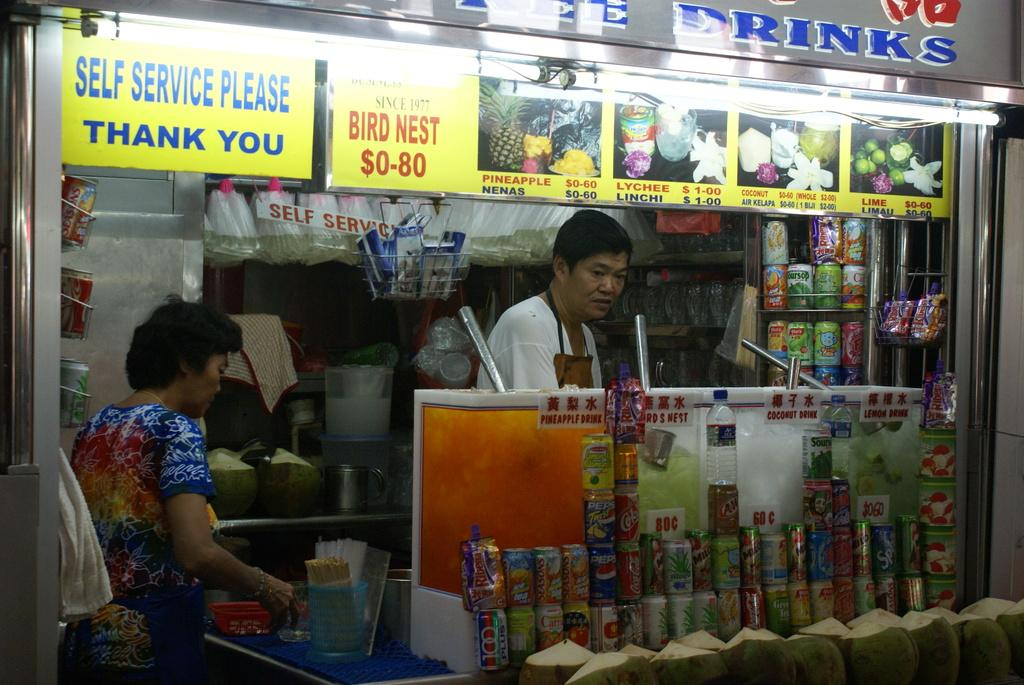<image>
Summarize the visual content of the image. A store front reads Self Service Please in blue. 